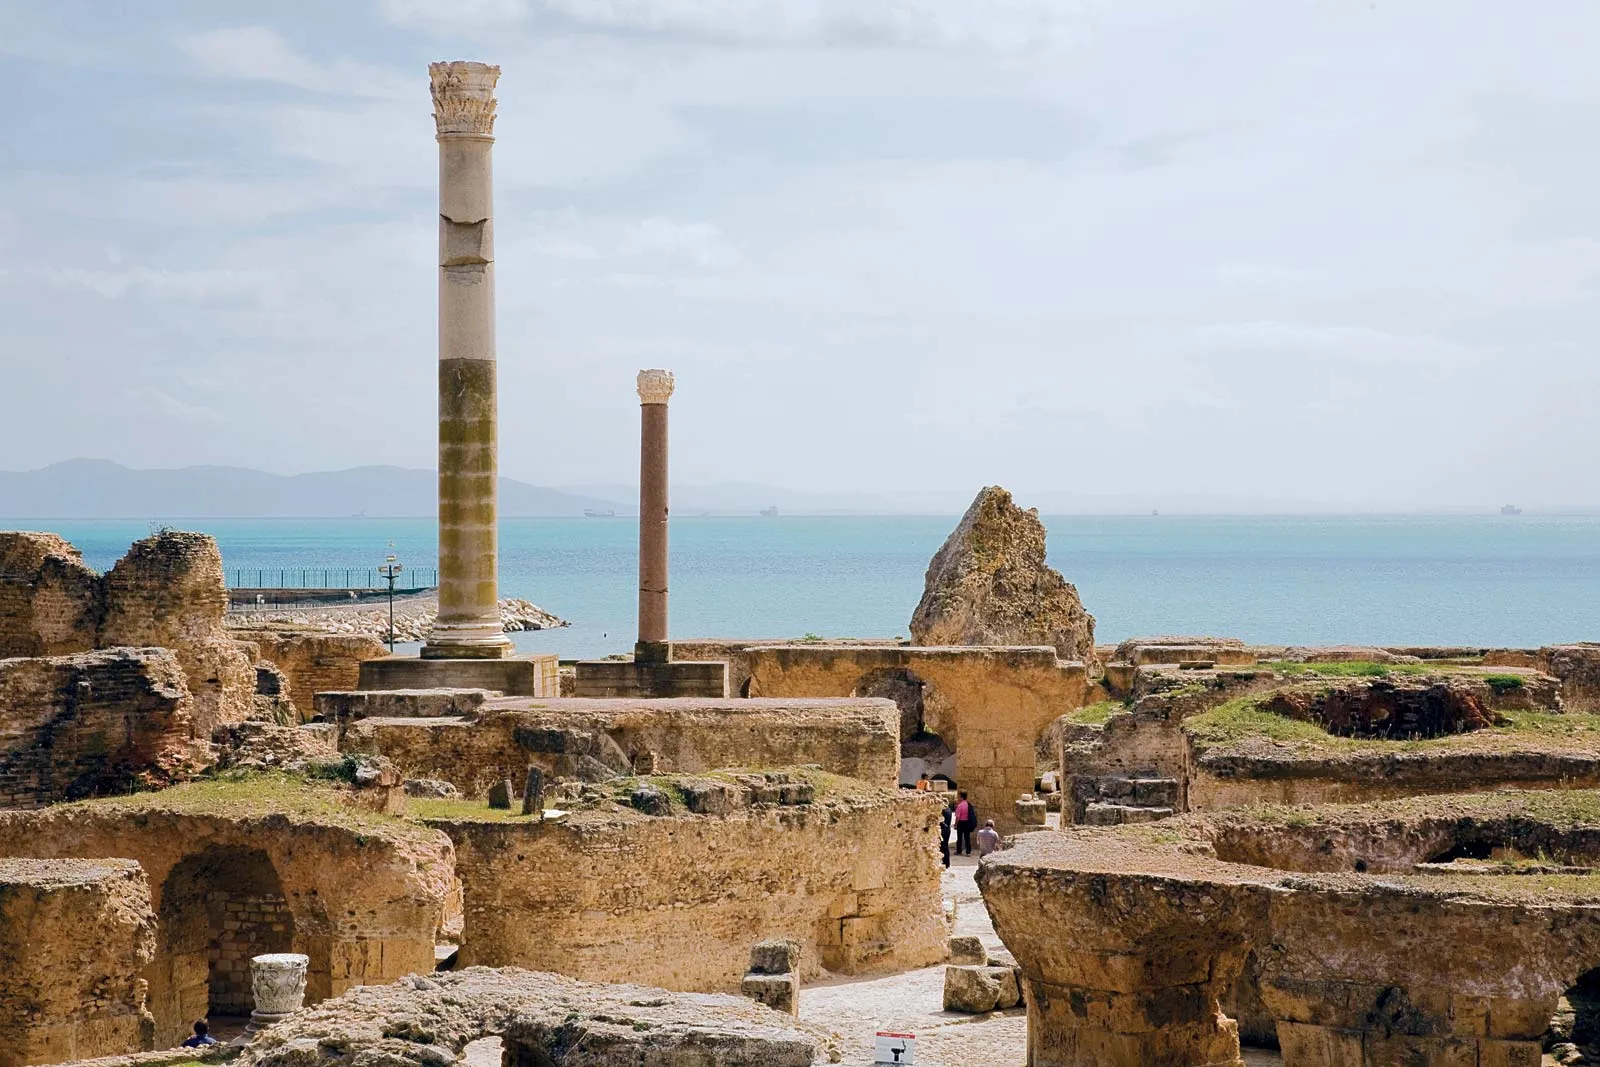How do the ruins of Carthage compare to other ancient cities? The ruins of Carthage are unique due to their blend of Phoenician and Roman influences, reflecting its history of destruction and rebirth. Unlike the more uniform architectural styles of ancient Roman sites like Pompeii or Herculaneum, Carthage displays layers of history that tell stories of cultural interchange and conflict. The seaside location also adds a dramatic backdrop that is less common in other ancient cities, providing a picturesque contrast between man-made structures and natural beauty. 